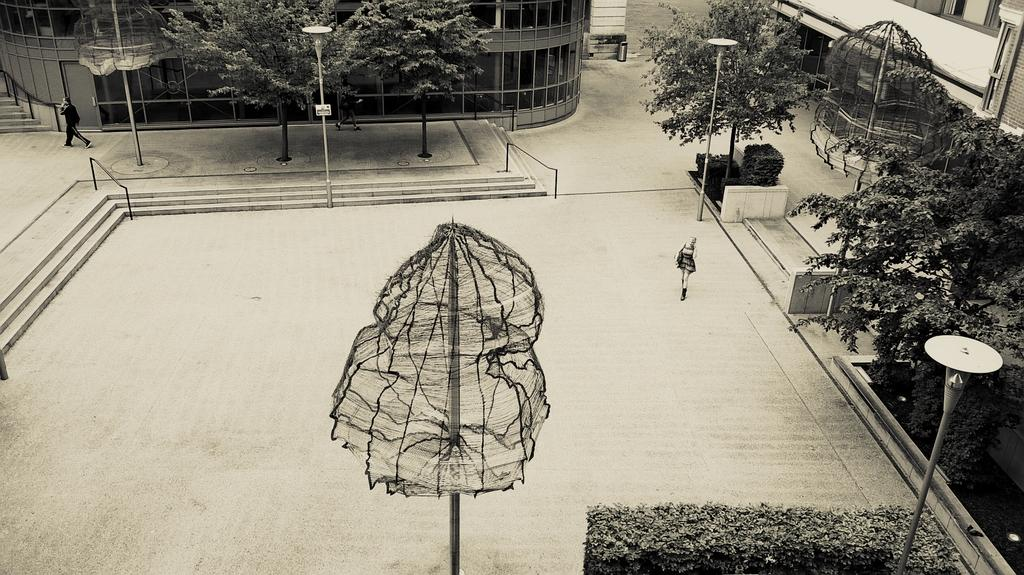What are the people in the image doing? The people in the image are walking. What are the people wearing while walking? The people are wearing clothes. What structures can be seen in the image? Light poles, stairs, a footpath, and buildings are visible in the image. What type of vegetation is present in the image? Trees and grass are present in the image. What type of pipe can be seen in the image? There is no pipe present in the image. What smell is associated with the image? The image does not convey any smells, as it is a visual medium. 